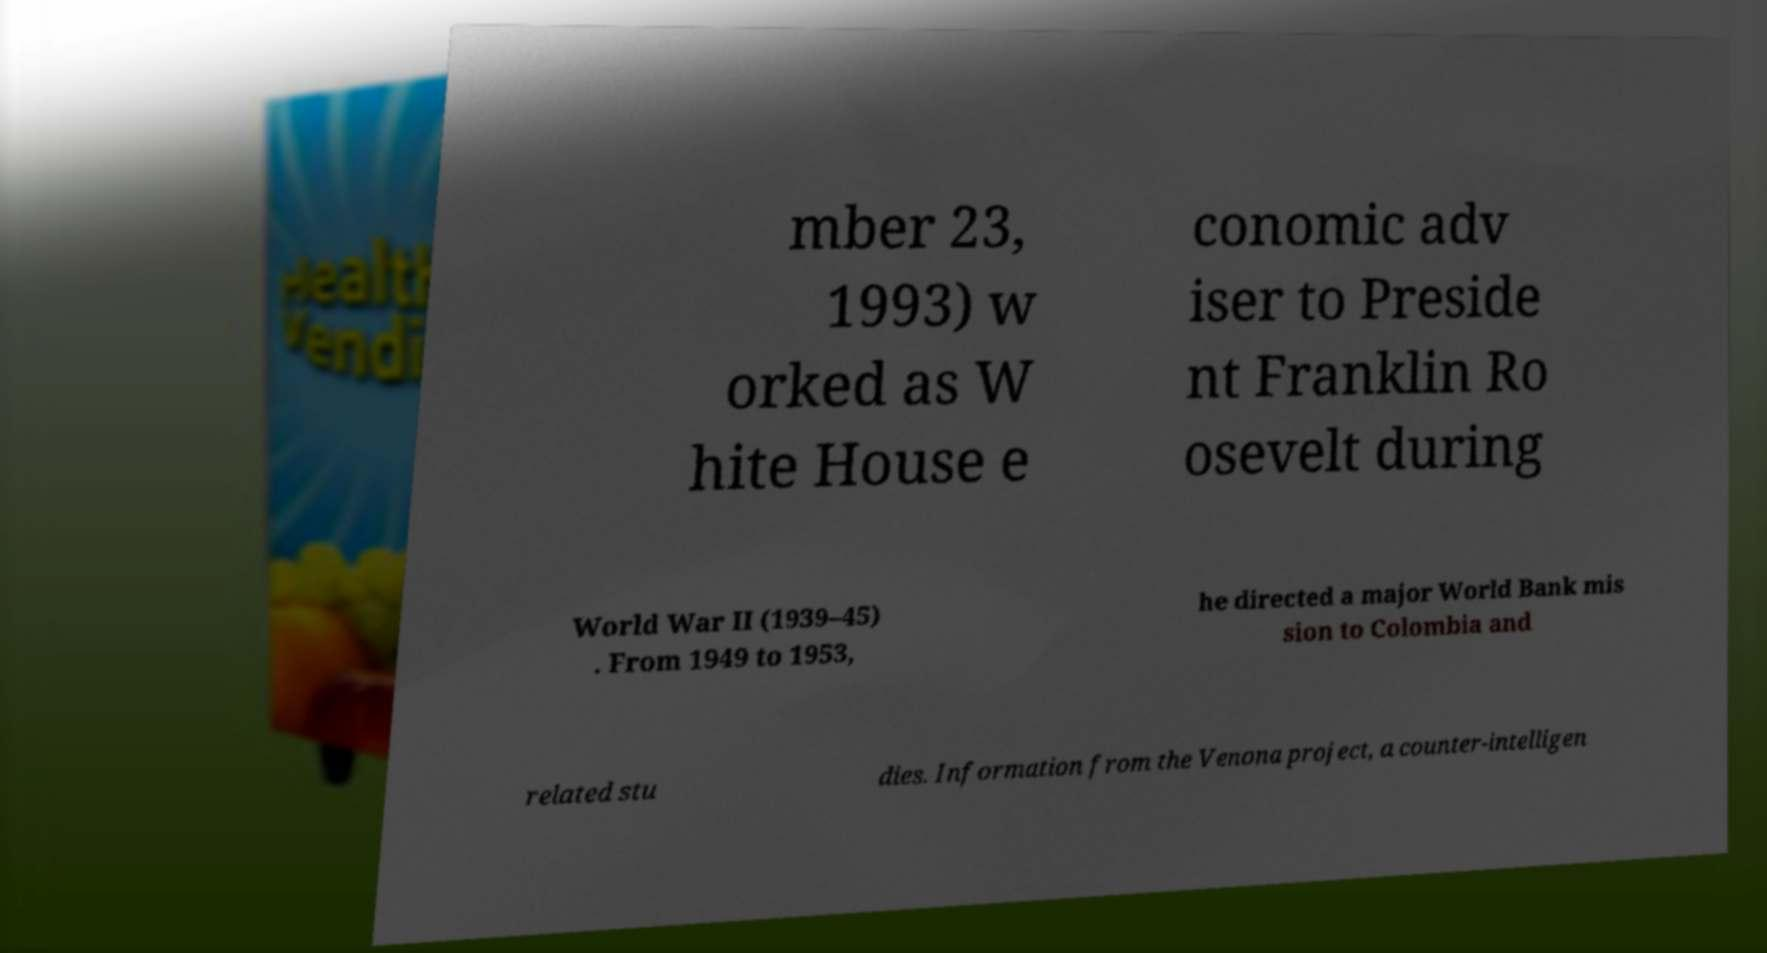Please identify and transcribe the text found in this image. mber 23, 1993) w orked as W hite House e conomic adv iser to Preside nt Franklin Ro osevelt during World War II (1939–45) . From 1949 to 1953, he directed a major World Bank mis sion to Colombia and related stu dies. Information from the Venona project, a counter-intelligen 